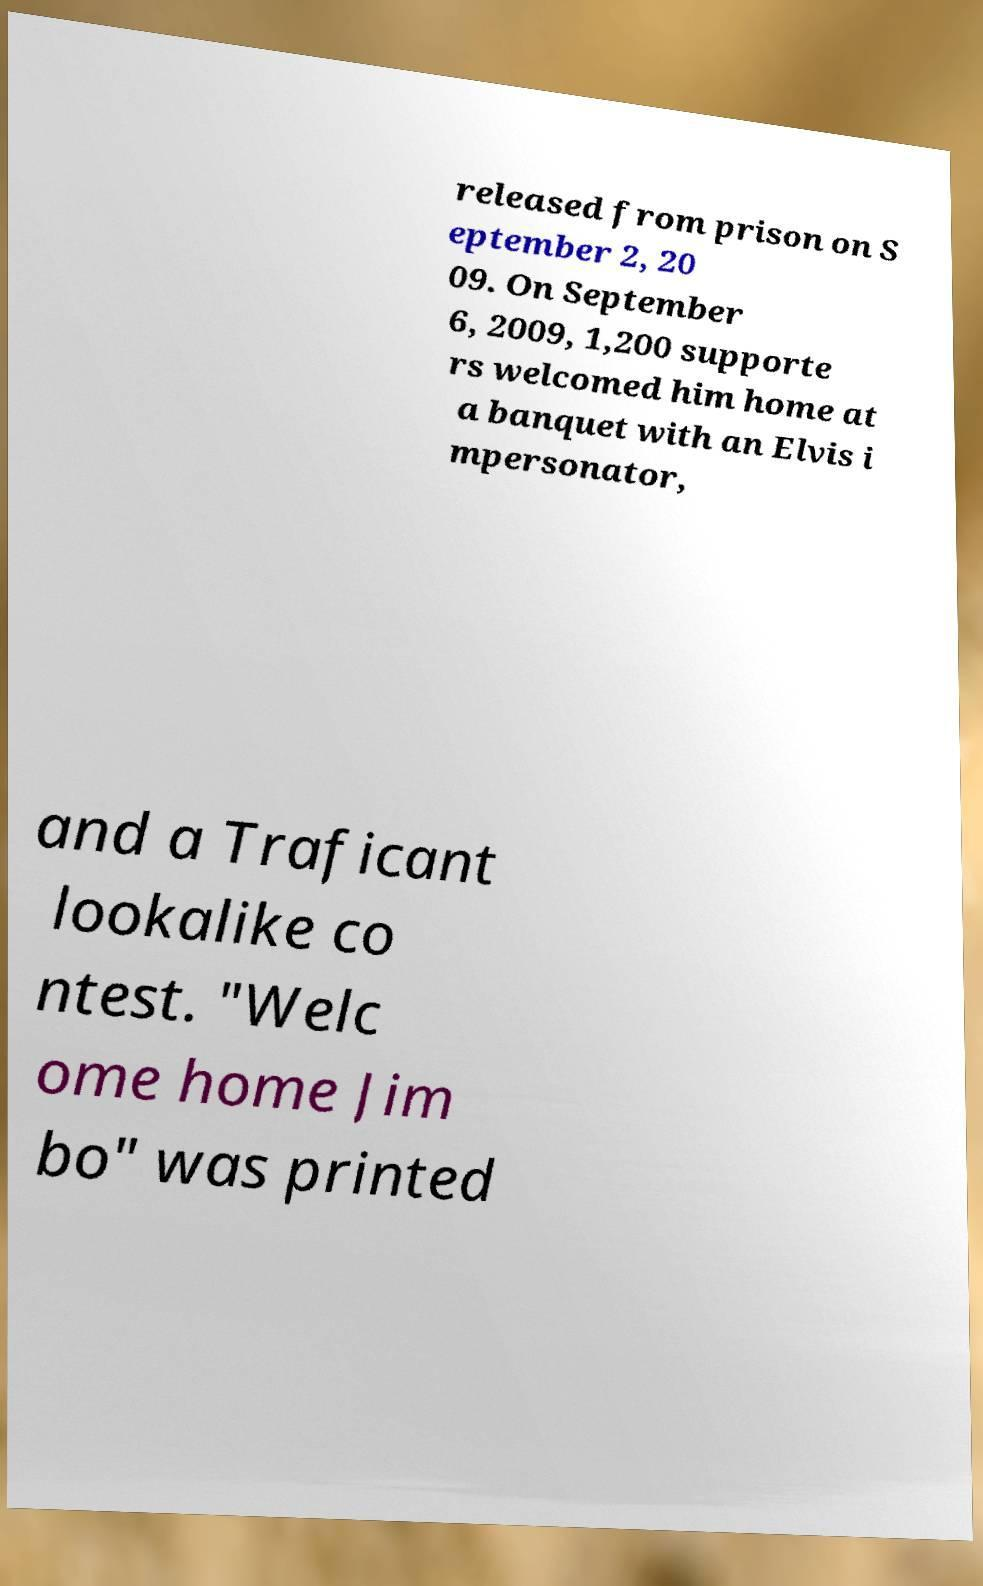I need the written content from this picture converted into text. Can you do that? released from prison on S eptember 2, 20 09. On September 6, 2009, 1,200 supporte rs welcomed him home at a banquet with an Elvis i mpersonator, and a Traficant lookalike co ntest. "Welc ome home Jim bo" was printed 